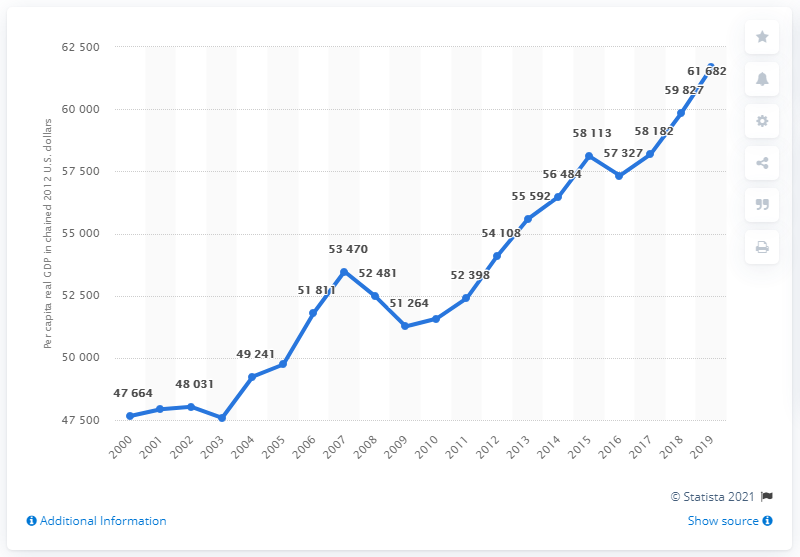Draw attention to some important aspects in this diagram. In the year 2012, the per capita real GDP of Texas stood at a value of 61,682, when adjusted for inflation. 